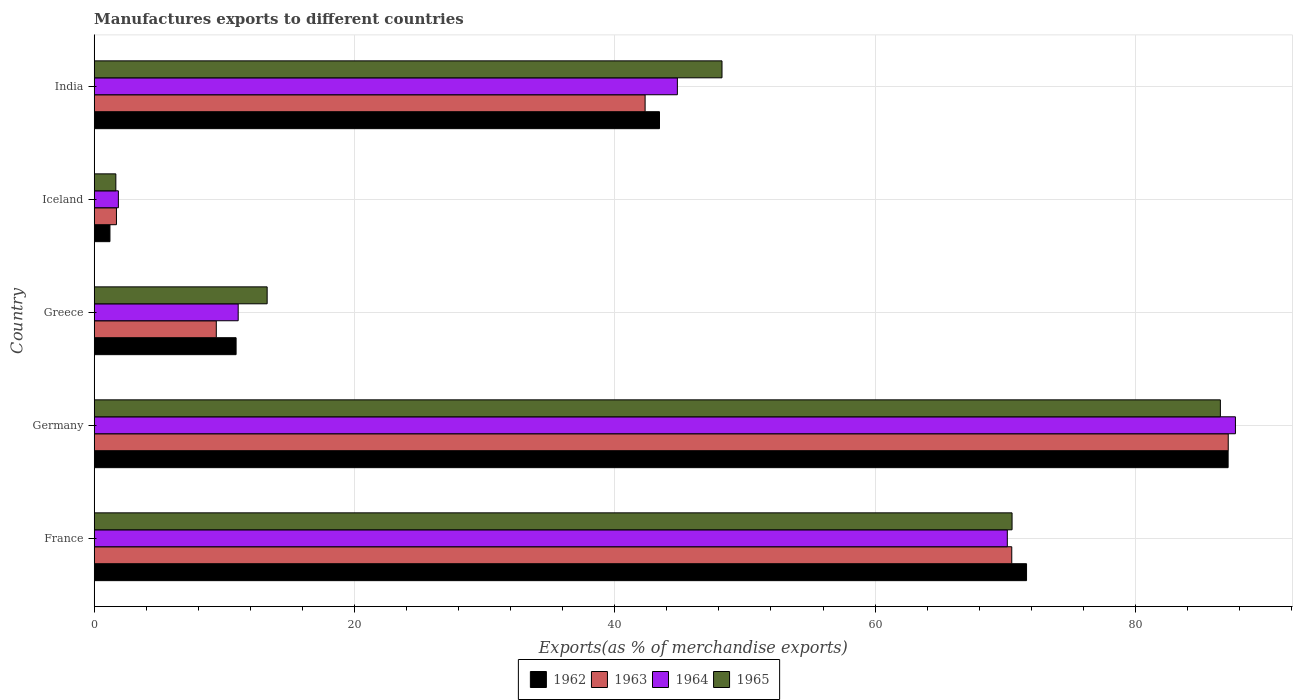How many groups of bars are there?
Offer a terse response. 5. How many bars are there on the 1st tick from the top?
Make the answer very short. 4. In how many cases, is the number of bars for a given country not equal to the number of legend labels?
Keep it short and to the point. 0. What is the percentage of exports to different countries in 1965 in France?
Your response must be concise. 70.52. Across all countries, what is the maximum percentage of exports to different countries in 1965?
Keep it short and to the point. 86.53. Across all countries, what is the minimum percentage of exports to different countries in 1963?
Your answer should be very brief. 1.71. In which country was the percentage of exports to different countries in 1963 minimum?
Provide a succinct answer. Iceland. What is the total percentage of exports to different countries in 1962 in the graph?
Provide a short and direct response. 214.31. What is the difference between the percentage of exports to different countries in 1964 in France and that in Greece?
Ensure brevity in your answer.  59.1. What is the difference between the percentage of exports to different countries in 1963 in France and the percentage of exports to different countries in 1962 in Germany?
Your response must be concise. -16.62. What is the average percentage of exports to different countries in 1963 per country?
Offer a terse response. 42.21. What is the difference between the percentage of exports to different countries in 1965 and percentage of exports to different countries in 1964 in Iceland?
Offer a very short reply. -0.19. In how many countries, is the percentage of exports to different countries in 1965 greater than 88 %?
Provide a succinct answer. 0. What is the ratio of the percentage of exports to different countries in 1965 in France to that in Greece?
Make the answer very short. 5.31. Is the difference between the percentage of exports to different countries in 1965 in Greece and India greater than the difference between the percentage of exports to different countries in 1964 in Greece and India?
Keep it short and to the point. No. What is the difference between the highest and the second highest percentage of exports to different countries in 1962?
Keep it short and to the point. 15.49. What is the difference between the highest and the lowest percentage of exports to different countries in 1964?
Give a very brief answer. 85.83. In how many countries, is the percentage of exports to different countries in 1963 greater than the average percentage of exports to different countries in 1963 taken over all countries?
Keep it short and to the point. 3. Is the sum of the percentage of exports to different countries in 1963 in Iceland and India greater than the maximum percentage of exports to different countries in 1965 across all countries?
Give a very brief answer. No. Is it the case that in every country, the sum of the percentage of exports to different countries in 1962 and percentage of exports to different countries in 1964 is greater than the sum of percentage of exports to different countries in 1963 and percentage of exports to different countries in 1965?
Your answer should be very brief. No. What does the 3rd bar from the bottom in Iceland represents?
Keep it short and to the point. 1964. Is it the case that in every country, the sum of the percentage of exports to different countries in 1965 and percentage of exports to different countries in 1962 is greater than the percentage of exports to different countries in 1964?
Your answer should be very brief. Yes. How many bars are there?
Your answer should be very brief. 20. Where does the legend appear in the graph?
Give a very brief answer. Bottom center. How many legend labels are there?
Provide a succinct answer. 4. What is the title of the graph?
Provide a short and direct response. Manufactures exports to different countries. Does "1972" appear as one of the legend labels in the graph?
Offer a very short reply. No. What is the label or title of the X-axis?
Give a very brief answer. Exports(as % of merchandise exports). What is the Exports(as % of merchandise exports) of 1962 in France?
Provide a succinct answer. 71.64. What is the Exports(as % of merchandise exports) of 1963 in France?
Your response must be concise. 70.5. What is the Exports(as % of merchandise exports) of 1964 in France?
Your answer should be very brief. 70.16. What is the Exports(as % of merchandise exports) in 1965 in France?
Keep it short and to the point. 70.52. What is the Exports(as % of merchandise exports) in 1962 in Germany?
Your answer should be compact. 87.12. What is the Exports(as % of merchandise exports) of 1963 in Germany?
Ensure brevity in your answer.  87.13. What is the Exports(as % of merchandise exports) of 1964 in Germany?
Ensure brevity in your answer.  87.69. What is the Exports(as % of merchandise exports) in 1965 in Germany?
Your answer should be compact. 86.53. What is the Exports(as % of merchandise exports) in 1962 in Greece?
Give a very brief answer. 10.9. What is the Exports(as % of merchandise exports) in 1963 in Greece?
Give a very brief answer. 9.38. What is the Exports(as % of merchandise exports) of 1964 in Greece?
Provide a short and direct response. 11.06. What is the Exports(as % of merchandise exports) in 1965 in Greece?
Your answer should be very brief. 13.29. What is the Exports(as % of merchandise exports) of 1962 in Iceland?
Your response must be concise. 1.21. What is the Exports(as % of merchandise exports) in 1963 in Iceland?
Offer a terse response. 1.71. What is the Exports(as % of merchandise exports) of 1964 in Iceland?
Offer a terse response. 1.86. What is the Exports(as % of merchandise exports) of 1965 in Iceland?
Provide a succinct answer. 1.66. What is the Exports(as % of merchandise exports) of 1962 in India?
Keep it short and to the point. 43.43. What is the Exports(as % of merchandise exports) in 1963 in India?
Give a very brief answer. 42.33. What is the Exports(as % of merchandise exports) of 1964 in India?
Your response must be concise. 44.81. What is the Exports(as % of merchandise exports) in 1965 in India?
Make the answer very short. 48.24. Across all countries, what is the maximum Exports(as % of merchandise exports) of 1962?
Your answer should be very brief. 87.12. Across all countries, what is the maximum Exports(as % of merchandise exports) of 1963?
Your answer should be compact. 87.13. Across all countries, what is the maximum Exports(as % of merchandise exports) in 1964?
Your response must be concise. 87.69. Across all countries, what is the maximum Exports(as % of merchandise exports) in 1965?
Make the answer very short. 86.53. Across all countries, what is the minimum Exports(as % of merchandise exports) of 1962?
Your response must be concise. 1.21. Across all countries, what is the minimum Exports(as % of merchandise exports) of 1963?
Your response must be concise. 1.71. Across all countries, what is the minimum Exports(as % of merchandise exports) of 1964?
Keep it short and to the point. 1.86. Across all countries, what is the minimum Exports(as % of merchandise exports) of 1965?
Your answer should be compact. 1.66. What is the total Exports(as % of merchandise exports) of 1962 in the graph?
Your answer should be very brief. 214.31. What is the total Exports(as % of merchandise exports) in 1963 in the graph?
Keep it short and to the point. 211.05. What is the total Exports(as % of merchandise exports) of 1964 in the graph?
Give a very brief answer. 215.57. What is the total Exports(as % of merchandise exports) of 1965 in the graph?
Make the answer very short. 220.24. What is the difference between the Exports(as % of merchandise exports) of 1962 in France and that in Germany?
Keep it short and to the point. -15.49. What is the difference between the Exports(as % of merchandise exports) of 1963 in France and that in Germany?
Your response must be concise. -16.63. What is the difference between the Exports(as % of merchandise exports) of 1964 in France and that in Germany?
Your answer should be very brief. -17.53. What is the difference between the Exports(as % of merchandise exports) of 1965 in France and that in Germany?
Give a very brief answer. -16.01. What is the difference between the Exports(as % of merchandise exports) in 1962 in France and that in Greece?
Your response must be concise. 60.73. What is the difference between the Exports(as % of merchandise exports) in 1963 in France and that in Greece?
Ensure brevity in your answer.  61.12. What is the difference between the Exports(as % of merchandise exports) in 1964 in France and that in Greece?
Your answer should be compact. 59.1. What is the difference between the Exports(as % of merchandise exports) in 1965 in France and that in Greece?
Your answer should be compact. 57.23. What is the difference between the Exports(as % of merchandise exports) of 1962 in France and that in Iceland?
Provide a succinct answer. 70.43. What is the difference between the Exports(as % of merchandise exports) in 1963 in France and that in Iceland?
Offer a very short reply. 68.79. What is the difference between the Exports(as % of merchandise exports) of 1964 in France and that in Iceland?
Make the answer very short. 68.3. What is the difference between the Exports(as % of merchandise exports) in 1965 in France and that in Iceland?
Your answer should be compact. 68.86. What is the difference between the Exports(as % of merchandise exports) of 1962 in France and that in India?
Give a very brief answer. 28.2. What is the difference between the Exports(as % of merchandise exports) of 1963 in France and that in India?
Your response must be concise. 28.17. What is the difference between the Exports(as % of merchandise exports) of 1964 in France and that in India?
Provide a succinct answer. 25.35. What is the difference between the Exports(as % of merchandise exports) of 1965 in France and that in India?
Give a very brief answer. 22.29. What is the difference between the Exports(as % of merchandise exports) in 1962 in Germany and that in Greece?
Ensure brevity in your answer.  76.22. What is the difference between the Exports(as % of merchandise exports) in 1963 in Germany and that in Greece?
Keep it short and to the point. 77.75. What is the difference between the Exports(as % of merchandise exports) in 1964 in Germany and that in Greece?
Ensure brevity in your answer.  76.62. What is the difference between the Exports(as % of merchandise exports) in 1965 in Germany and that in Greece?
Provide a short and direct response. 73.24. What is the difference between the Exports(as % of merchandise exports) of 1962 in Germany and that in Iceland?
Your answer should be compact. 85.91. What is the difference between the Exports(as % of merchandise exports) in 1963 in Germany and that in Iceland?
Offer a terse response. 85.42. What is the difference between the Exports(as % of merchandise exports) of 1964 in Germany and that in Iceland?
Make the answer very short. 85.83. What is the difference between the Exports(as % of merchandise exports) in 1965 in Germany and that in Iceland?
Your response must be concise. 84.86. What is the difference between the Exports(as % of merchandise exports) of 1962 in Germany and that in India?
Your answer should be very brief. 43.69. What is the difference between the Exports(as % of merchandise exports) in 1963 in Germany and that in India?
Your response must be concise. 44.8. What is the difference between the Exports(as % of merchandise exports) in 1964 in Germany and that in India?
Keep it short and to the point. 42.88. What is the difference between the Exports(as % of merchandise exports) of 1965 in Germany and that in India?
Offer a terse response. 38.29. What is the difference between the Exports(as % of merchandise exports) in 1962 in Greece and that in Iceland?
Offer a terse response. 9.69. What is the difference between the Exports(as % of merchandise exports) of 1963 in Greece and that in Iceland?
Keep it short and to the point. 7.67. What is the difference between the Exports(as % of merchandise exports) in 1964 in Greece and that in Iceland?
Make the answer very short. 9.21. What is the difference between the Exports(as % of merchandise exports) of 1965 in Greece and that in Iceland?
Give a very brief answer. 11.63. What is the difference between the Exports(as % of merchandise exports) in 1962 in Greece and that in India?
Provide a succinct answer. -32.53. What is the difference between the Exports(as % of merchandise exports) of 1963 in Greece and that in India?
Give a very brief answer. -32.95. What is the difference between the Exports(as % of merchandise exports) in 1964 in Greece and that in India?
Keep it short and to the point. -33.74. What is the difference between the Exports(as % of merchandise exports) of 1965 in Greece and that in India?
Give a very brief answer. -34.95. What is the difference between the Exports(as % of merchandise exports) of 1962 in Iceland and that in India?
Your response must be concise. -42.22. What is the difference between the Exports(as % of merchandise exports) of 1963 in Iceland and that in India?
Ensure brevity in your answer.  -40.62. What is the difference between the Exports(as % of merchandise exports) in 1964 in Iceland and that in India?
Your answer should be very brief. -42.95. What is the difference between the Exports(as % of merchandise exports) of 1965 in Iceland and that in India?
Give a very brief answer. -46.57. What is the difference between the Exports(as % of merchandise exports) of 1962 in France and the Exports(as % of merchandise exports) of 1963 in Germany?
Give a very brief answer. -15.5. What is the difference between the Exports(as % of merchandise exports) in 1962 in France and the Exports(as % of merchandise exports) in 1964 in Germany?
Your response must be concise. -16.05. What is the difference between the Exports(as % of merchandise exports) of 1962 in France and the Exports(as % of merchandise exports) of 1965 in Germany?
Keep it short and to the point. -14.89. What is the difference between the Exports(as % of merchandise exports) in 1963 in France and the Exports(as % of merchandise exports) in 1964 in Germany?
Your response must be concise. -17.18. What is the difference between the Exports(as % of merchandise exports) in 1963 in France and the Exports(as % of merchandise exports) in 1965 in Germany?
Offer a very short reply. -16.03. What is the difference between the Exports(as % of merchandise exports) in 1964 in France and the Exports(as % of merchandise exports) in 1965 in Germany?
Your response must be concise. -16.37. What is the difference between the Exports(as % of merchandise exports) in 1962 in France and the Exports(as % of merchandise exports) in 1963 in Greece?
Give a very brief answer. 62.25. What is the difference between the Exports(as % of merchandise exports) of 1962 in France and the Exports(as % of merchandise exports) of 1964 in Greece?
Provide a short and direct response. 60.57. What is the difference between the Exports(as % of merchandise exports) of 1962 in France and the Exports(as % of merchandise exports) of 1965 in Greece?
Your answer should be compact. 58.35. What is the difference between the Exports(as % of merchandise exports) of 1963 in France and the Exports(as % of merchandise exports) of 1964 in Greece?
Make the answer very short. 59.44. What is the difference between the Exports(as % of merchandise exports) of 1963 in France and the Exports(as % of merchandise exports) of 1965 in Greece?
Give a very brief answer. 57.21. What is the difference between the Exports(as % of merchandise exports) of 1964 in France and the Exports(as % of merchandise exports) of 1965 in Greece?
Ensure brevity in your answer.  56.87. What is the difference between the Exports(as % of merchandise exports) in 1962 in France and the Exports(as % of merchandise exports) in 1963 in Iceland?
Your answer should be compact. 69.93. What is the difference between the Exports(as % of merchandise exports) of 1962 in France and the Exports(as % of merchandise exports) of 1964 in Iceland?
Your response must be concise. 69.78. What is the difference between the Exports(as % of merchandise exports) of 1962 in France and the Exports(as % of merchandise exports) of 1965 in Iceland?
Offer a terse response. 69.97. What is the difference between the Exports(as % of merchandise exports) of 1963 in France and the Exports(as % of merchandise exports) of 1964 in Iceland?
Your answer should be compact. 68.64. What is the difference between the Exports(as % of merchandise exports) in 1963 in France and the Exports(as % of merchandise exports) in 1965 in Iceland?
Offer a very short reply. 68.84. What is the difference between the Exports(as % of merchandise exports) of 1964 in France and the Exports(as % of merchandise exports) of 1965 in Iceland?
Make the answer very short. 68.5. What is the difference between the Exports(as % of merchandise exports) in 1962 in France and the Exports(as % of merchandise exports) in 1963 in India?
Offer a terse response. 29.31. What is the difference between the Exports(as % of merchandise exports) of 1962 in France and the Exports(as % of merchandise exports) of 1964 in India?
Your answer should be very brief. 26.83. What is the difference between the Exports(as % of merchandise exports) of 1962 in France and the Exports(as % of merchandise exports) of 1965 in India?
Ensure brevity in your answer.  23.4. What is the difference between the Exports(as % of merchandise exports) in 1963 in France and the Exports(as % of merchandise exports) in 1964 in India?
Offer a very short reply. 25.69. What is the difference between the Exports(as % of merchandise exports) in 1963 in France and the Exports(as % of merchandise exports) in 1965 in India?
Ensure brevity in your answer.  22.26. What is the difference between the Exports(as % of merchandise exports) of 1964 in France and the Exports(as % of merchandise exports) of 1965 in India?
Ensure brevity in your answer.  21.92. What is the difference between the Exports(as % of merchandise exports) in 1962 in Germany and the Exports(as % of merchandise exports) in 1963 in Greece?
Your answer should be very brief. 77.74. What is the difference between the Exports(as % of merchandise exports) in 1962 in Germany and the Exports(as % of merchandise exports) in 1964 in Greece?
Keep it short and to the point. 76.06. What is the difference between the Exports(as % of merchandise exports) in 1962 in Germany and the Exports(as % of merchandise exports) in 1965 in Greece?
Offer a terse response. 73.84. What is the difference between the Exports(as % of merchandise exports) in 1963 in Germany and the Exports(as % of merchandise exports) in 1964 in Greece?
Give a very brief answer. 76.07. What is the difference between the Exports(as % of merchandise exports) in 1963 in Germany and the Exports(as % of merchandise exports) in 1965 in Greece?
Your response must be concise. 73.84. What is the difference between the Exports(as % of merchandise exports) in 1964 in Germany and the Exports(as % of merchandise exports) in 1965 in Greece?
Your response must be concise. 74.4. What is the difference between the Exports(as % of merchandise exports) of 1962 in Germany and the Exports(as % of merchandise exports) of 1963 in Iceland?
Offer a very short reply. 85.41. What is the difference between the Exports(as % of merchandise exports) in 1962 in Germany and the Exports(as % of merchandise exports) in 1964 in Iceland?
Offer a terse response. 85.27. What is the difference between the Exports(as % of merchandise exports) of 1962 in Germany and the Exports(as % of merchandise exports) of 1965 in Iceland?
Offer a terse response. 85.46. What is the difference between the Exports(as % of merchandise exports) in 1963 in Germany and the Exports(as % of merchandise exports) in 1964 in Iceland?
Offer a very short reply. 85.28. What is the difference between the Exports(as % of merchandise exports) of 1963 in Germany and the Exports(as % of merchandise exports) of 1965 in Iceland?
Your answer should be very brief. 85.47. What is the difference between the Exports(as % of merchandise exports) of 1964 in Germany and the Exports(as % of merchandise exports) of 1965 in Iceland?
Give a very brief answer. 86.02. What is the difference between the Exports(as % of merchandise exports) of 1962 in Germany and the Exports(as % of merchandise exports) of 1963 in India?
Make the answer very short. 44.8. What is the difference between the Exports(as % of merchandise exports) in 1962 in Germany and the Exports(as % of merchandise exports) in 1964 in India?
Your answer should be very brief. 42.32. What is the difference between the Exports(as % of merchandise exports) of 1962 in Germany and the Exports(as % of merchandise exports) of 1965 in India?
Provide a succinct answer. 38.89. What is the difference between the Exports(as % of merchandise exports) of 1963 in Germany and the Exports(as % of merchandise exports) of 1964 in India?
Your response must be concise. 42.33. What is the difference between the Exports(as % of merchandise exports) in 1963 in Germany and the Exports(as % of merchandise exports) in 1965 in India?
Keep it short and to the point. 38.9. What is the difference between the Exports(as % of merchandise exports) of 1964 in Germany and the Exports(as % of merchandise exports) of 1965 in India?
Keep it short and to the point. 39.45. What is the difference between the Exports(as % of merchandise exports) of 1962 in Greece and the Exports(as % of merchandise exports) of 1963 in Iceland?
Offer a terse response. 9.19. What is the difference between the Exports(as % of merchandise exports) in 1962 in Greece and the Exports(as % of merchandise exports) in 1964 in Iceland?
Provide a succinct answer. 9.05. What is the difference between the Exports(as % of merchandise exports) of 1962 in Greece and the Exports(as % of merchandise exports) of 1965 in Iceland?
Offer a very short reply. 9.24. What is the difference between the Exports(as % of merchandise exports) of 1963 in Greece and the Exports(as % of merchandise exports) of 1964 in Iceland?
Provide a succinct answer. 7.52. What is the difference between the Exports(as % of merchandise exports) in 1963 in Greece and the Exports(as % of merchandise exports) in 1965 in Iceland?
Provide a succinct answer. 7.72. What is the difference between the Exports(as % of merchandise exports) in 1964 in Greece and the Exports(as % of merchandise exports) in 1965 in Iceland?
Offer a terse response. 9.4. What is the difference between the Exports(as % of merchandise exports) of 1962 in Greece and the Exports(as % of merchandise exports) of 1963 in India?
Make the answer very short. -31.43. What is the difference between the Exports(as % of merchandise exports) of 1962 in Greece and the Exports(as % of merchandise exports) of 1964 in India?
Offer a terse response. -33.91. What is the difference between the Exports(as % of merchandise exports) in 1962 in Greece and the Exports(as % of merchandise exports) in 1965 in India?
Ensure brevity in your answer.  -37.33. What is the difference between the Exports(as % of merchandise exports) in 1963 in Greece and the Exports(as % of merchandise exports) in 1964 in India?
Give a very brief answer. -35.43. What is the difference between the Exports(as % of merchandise exports) of 1963 in Greece and the Exports(as % of merchandise exports) of 1965 in India?
Keep it short and to the point. -38.86. What is the difference between the Exports(as % of merchandise exports) in 1964 in Greece and the Exports(as % of merchandise exports) in 1965 in India?
Provide a succinct answer. -37.17. What is the difference between the Exports(as % of merchandise exports) in 1962 in Iceland and the Exports(as % of merchandise exports) in 1963 in India?
Keep it short and to the point. -41.12. What is the difference between the Exports(as % of merchandise exports) of 1962 in Iceland and the Exports(as % of merchandise exports) of 1964 in India?
Provide a short and direct response. -43.6. What is the difference between the Exports(as % of merchandise exports) of 1962 in Iceland and the Exports(as % of merchandise exports) of 1965 in India?
Ensure brevity in your answer.  -47.03. What is the difference between the Exports(as % of merchandise exports) in 1963 in Iceland and the Exports(as % of merchandise exports) in 1964 in India?
Your answer should be very brief. -43.1. What is the difference between the Exports(as % of merchandise exports) of 1963 in Iceland and the Exports(as % of merchandise exports) of 1965 in India?
Ensure brevity in your answer.  -46.53. What is the difference between the Exports(as % of merchandise exports) of 1964 in Iceland and the Exports(as % of merchandise exports) of 1965 in India?
Ensure brevity in your answer.  -46.38. What is the average Exports(as % of merchandise exports) in 1962 per country?
Offer a very short reply. 42.86. What is the average Exports(as % of merchandise exports) in 1963 per country?
Ensure brevity in your answer.  42.21. What is the average Exports(as % of merchandise exports) of 1964 per country?
Provide a short and direct response. 43.11. What is the average Exports(as % of merchandise exports) of 1965 per country?
Provide a short and direct response. 44.05. What is the difference between the Exports(as % of merchandise exports) of 1962 and Exports(as % of merchandise exports) of 1963 in France?
Your response must be concise. 1.13. What is the difference between the Exports(as % of merchandise exports) in 1962 and Exports(as % of merchandise exports) in 1964 in France?
Keep it short and to the point. 1.48. What is the difference between the Exports(as % of merchandise exports) of 1962 and Exports(as % of merchandise exports) of 1965 in France?
Ensure brevity in your answer.  1.11. What is the difference between the Exports(as % of merchandise exports) in 1963 and Exports(as % of merchandise exports) in 1964 in France?
Provide a succinct answer. 0.34. What is the difference between the Exports(as % of merchandise exports) of 1963 and Exports(as % of merchandise exports) of 1965 in France?
Provide a short and direct response. -0.02. What is the difference between the Exports(as % of merchandise exports) of 1964 and Exports(as % of merchandise exports) of 1965 in France?
Your answer should be compact. -0.36. What is the difference between the Exports(as % of merchandise exports) in 1962 and Exports(as % of merchandise exports) in 1963 in Germany?
Your response must be concise. -0.01. What is the difference between the Exports(as % of merchandise exports) in 1962 and Exports(as % of merchandise exports) in 1964 in Germany?
Keep it short and to the point. -0.56. What is the difference between the Exports(as % of merchandise exports) in 1962 and Exports(as % of merchandise exports) in 1965 in Germany?
Offer a very short reply. 0.6. What is the difference between the Exports(as % of merchandise exports) in 1963 and Exports(as % of merchandise exports) in 1964 in Germany?
Make the answer very short. -0.55. What is the difference between the Exports(as % of merchandise exports) of 1963 and Exports(as % of merchandise exports) of 1965 in Germany?
Keep it short and to the point. 0.6. What is the difference between the Exports(as % of merchandise exports) of 1964 and Exports(as % of merchandise exports) of 1965 in Germany?
Keep it short and to the point. 1.16. What is the difference between the Exports(as % of merchandise exports) in 1962 and Exports(as % of merchandise exports) in 1963 in Greece?
Offer a very short reply. 1.52. What is the difference between the Exports(as % of merchandise exports) of 1962 and Exports(as % of merchandise exports) of 1964 in Greece?
Offer a very short reply. -0.16. What is the difference between the Exports(as % of merchandise exports) in 1962 and Exports(as % of merchandise exports) in 1965 in Greece?
Keep it short and to the point. -2.39. What is the difference between the Exports(as % of merchandise exports) of 1963 and Exports(as % of merchandise exports) of 1964 in Greece?
Ensure brevity in your answer.  -1.68. What is the difference between the Exports(as % of merchandise exports) of 1963 and Exports(as % of merchandise exports) of 1965 in Greece?
Your answer should be compact. -3.91. What is the difference between the Exports(as % of merchandise exports) of 1964 and Exports(as % of merchandise exports) of 1965 in Greece?
Ensure brevity in your answer.  -2.23. What is the difference between the Exports(as % of merchandise exports) of 1962 and Exports(as % of merchandise exports) of 1964 in Iceland?
Your response must be concise. -0.65. What is the difference between the Exports(as % of merchandise exports) of 1962 and Exports(as % of merchandise exports) of 1965 in Iceland?
Provide a short and direct response. -0.45. What is the difference between the Exports(as % of merchandise exports) of 1963 and Exports(as % of merchandise exports) of 1964 in Iceland?
Your answer should be compact. -0.15. What is the difference between the Exports(as % of merchandise exports) of 1963 and Exports(as % of merchandise exports) of 1965 in Iceland?
Make the answer very short. 0.05. What is the difference between the Exports(as % of merchandise exports) in 1964 and Exports(as % of merchandise exports) in 1965 in Iceland?
Ensure brevity in your answer.  0.19. What is the difference between the Exports(as % of merchandise exports) of 1962 and Exports(as % of merchandise exports) of 1963 in India?
Offer a terse response. 1.11. What is the difference between the Exports(as % of merchandise exports) of 1962 and Exports(as % of merchandise exports) of 1964 in India?
Offer a terse response. -1.37. What is the difference between the Exports(as % of merchandise exports) in 1962 and Exports(as % of merchandise exports) in 1965 in India?
Offer a terse response. -4.8. What is the difference between the Exports(as % of merchandise exports) in 1963 and Exports(as % of merchandise exports) in 1964 in India?
Your response must be concise. -2.48. What is the difference between the Exports(as % of merchandise exports) in 1963 and Exports(as % of merchandise exports) in 1965 in India?
Your answer should be very brief. -5.91. What is the difference between the Exports(as % of merchandise exports) of 1964 and Exports(as % of merchandise exports) of 1965 in India?
Keep it short and to the point. -3.43. What is the ratio of the Exports(as % of merchandise exports) of 1962 in France to that in Germany?
Offer a very short reply. 0.82. What is the ratio of the Exports(as % of merchandise exports) of 1963 in France to that in Germany?
Your answer should be very brief. 0.81. What is the ratio of the Exports(as % of merchandise exports) in 1964 in France to that in Germany?
Keep it short and to the point. 0.8. What is the ratio of the Exports(as % of merchandise exports) of 1965 in France to that in Germany?
Make the answer very short. 0.81. What is the ratio of the Exports(as % of merchandise exports) of 1962 in France to that in Greece?
Give a very brief answer. 6.57. What is the ratio of the Exports(as % of merchandise exports) in 1963 in France to that in Greece?
Your answer should be very brief. 7.51. What is the ratio of the Exports(as % of merchandise exports) in 1964 in France to that in Greece?
Keep it short and to the point. 6.34. What is the ratio of the Exports(as % of merchandise exports) in 1965 in France to that in Greece?
Offer a terse response. 5.31. What is the ratio of the Exports(as % of merchandise exports) of 1962 in France to that in Iceland?
Your answer should be compact. 59.19. What is the ratio of the Exports(as % of merchandise exports) of 1963 in France to that in Iceland?
Offer a very short reply. 41.22. What is the ratio of the Exports(as % of merchandise exports) in 1964 in France to that in Iceland?
Offer a very short reply. 37.78. What is the ratio of the Exports(as % of merchandise exports) of 1965 in France to that in Iceland?
Offer a terse response. 42.4. What is the ratio of the Exports(as % of merchandise exports) in 1962 in France to that in India?
Your answer should be very brief. 1.65. What is the ratio of the Exports(as % of merchandise exports) in 1963 in France to that in India?
Offer a very short reply. 1.67. What is the ratio of the Exports(as % of merchandise exports) of 1964 in France to that in India?
Your answer should be very brief. 1.57. What is the ratio of the Exports(as % of merchandise exports) in 1965 in France to that in India?
Offer a terse response. 1.46. What is the ratio of the Exports(as % of merchandise exports) in 1962 in Germany to that in Greece?
Give a very brief answer. 7.99. What is the ratio of the Exports(as % of merchandise exports) of 1963 in Germany to that in Greece?
Offer a very short reply. 9.29. What is the ratio of the Exports(as % of merchandise exports) in 1964 in Germany to that in Greece?
Offer a terse response. 7.93. What is the ratio of the Exports(as % of merchandise exports) of 1965 in Germany to that in Greece?
Keep it short and to the point. 6.51. What is the ratio of the Exports(as % of merchandise exports) in 1962 in Germany to that in Iceland?
Offer a terse response. 71.98. What is the ratio of the Exports(as % of merchandise exports) of 1963 in Germany to that in Iceland?
Keep it short and to the point. 50.94. What is the ratio of the Exports(as % of merchandise exports) in 1964 in Germany to that in Iceland?
Provide a succinct answer. 47.21. What is the ratio of the Exports(as % of merchandise exports) in 1965 in Germany to that in Iceland?
Your answer should be very brief. 52.03. What is the ratio of the Exports(as % of merchandise exports) in 1962 in Germany to that in India?
Offer a very short reply. 2.01. What is the ratio of the Exports(as % of merchandise exports) of 1963 in Germany to that in India?
Your response must be concise. 2.06. What is the ratio of the Exports(as % of merchandise exports) in 1964 in Germany to that in India?
Give a very brief answer. 1.96. What is the ratio of the Exports(as % of merchandise exports) of 1965 in Germany to that in India?
Give a very brief answer. 1.79. What is the ratio of the Exports(as % of merchandise exports) of 1962 in Greece to that in Iceland?
Make the answer very short. 9.01. What is the ratio of the Exports(as % of merchandise exports) in 1963 in Greece to that in Iceland?
Your response must be concise. 5.49. What is the ratio of the Exports(as % of merchandise exports) of 1964 in Greece to that in Iceland?
Offer a very short reply. 5.96. What is the ratio of the Exports(as % of merchandise exports) of 1965 in Greece to that in Iceland?
Offer a very short reply. 7.99. What is the ratio of the Exports(as % of merchandise exports) of 1962 in Greece to that in India?
Keep it short and to the point. 0.25. What is the ratio of the Exports(as % of merchandise exports) in 1963 in Greece to that in India?
Keep it short and to the point. 0.22. What is the ratio of the Exports(as % of merchandise exports) in 1964 in Greece to that in India?
Give a very brief answer. 0.25. What is the ratio of the Exports(as % of merchandise exports) in 1965 in Greece to that in India?
Offer a terse response. 0.28. What is the ratio of the Exports(as % of merchandise exports) of 1962 in Iceland to that in India?
Your answer should be very brief. 0.03. What is the ratio of the Exports(as % of merchandise exports) in 1963 in Iceland to that in India?
Your response must be concise. 0.04. What is the ratio of the Exports(as % of merchandise exports) of 1964 in Iceland to that in India?
Your answer should be very brief. 0.04. What is the ratio of the Exports(as % of merchandise exports) in 1965 in Iceland to that in India?
Give a very brief answer. 0.03. What is the difference between the highest and the second highest Exports(as % of merchandise exports) in 1962?
Offer a terse response. 15.49. What is the difference between the highest and the second highest Exports(as % of merchandise exports) of 1963?
Keep it short and to the point. 16.63. What is the difference between the highest and the second highest Exports(as % of merchandise exports) of 1964?
Your answer should be compact. 17.53. What is the difference between the highest and the second highest Exports(as % of merchandise exports) in 1965?
Your response must be concise. 16.01. What is the difference between the highest and the lowest Exports(as % of merchandise exports) in 1962?
Offer a very short reply. 85.91. What is the difference between the highest and the lowest Exports(as % of merchandise exports) of 1963?
Your answer should be very brief. 85.42. What is the difference between the highest and the lowest Exports(as % of merchandise exports) in 1964?
Ensure brevity in your answer.  85.83. What is the difference between the highest and the lowest Exports(as % of merchandise exports) of 1965?
Your response must be concise. 84.86. 